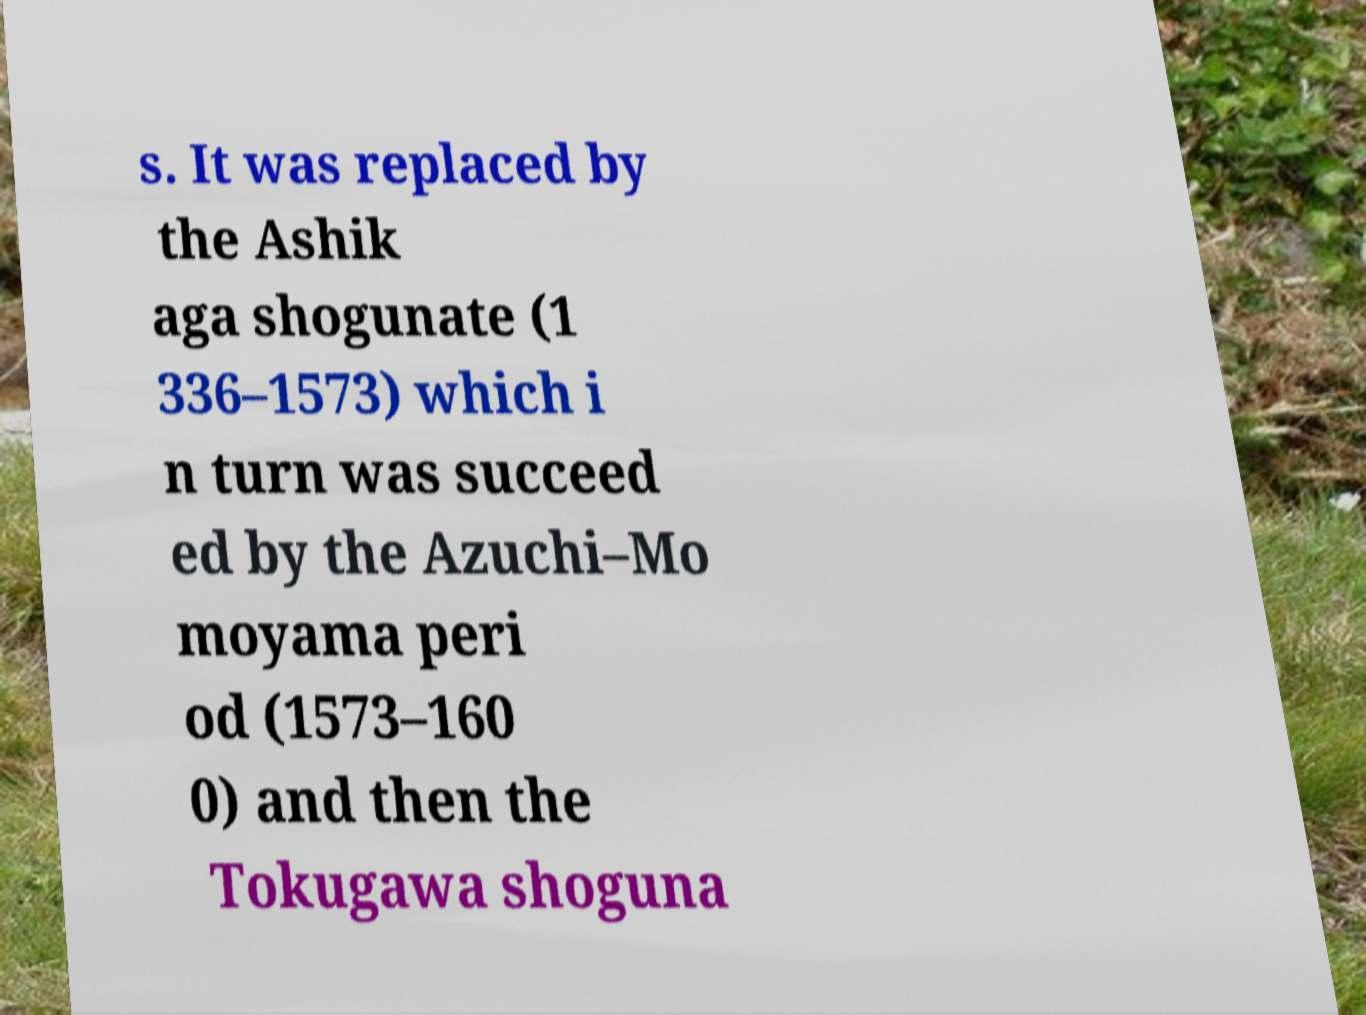There's text embedded in this image that I need extracted. Can you transcribe it verbatim? s. It was replaced by the Ashik aga shogunate (1 336–1573) which i n turn was succeed ed by the Azuchi–Mo moyama peri od (1573–160 0) and then the Tokugawa shoguna 